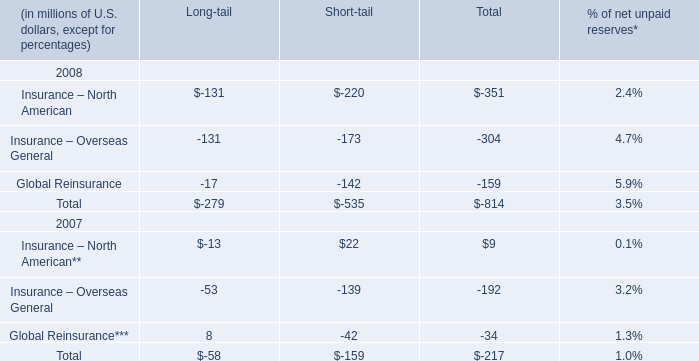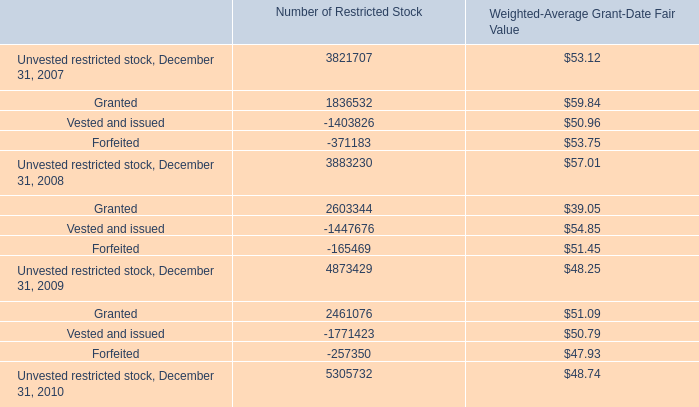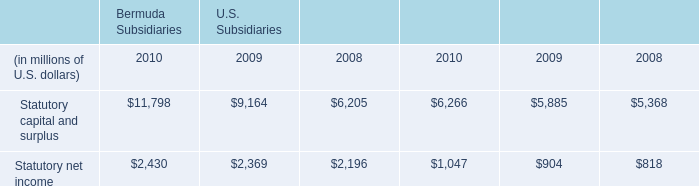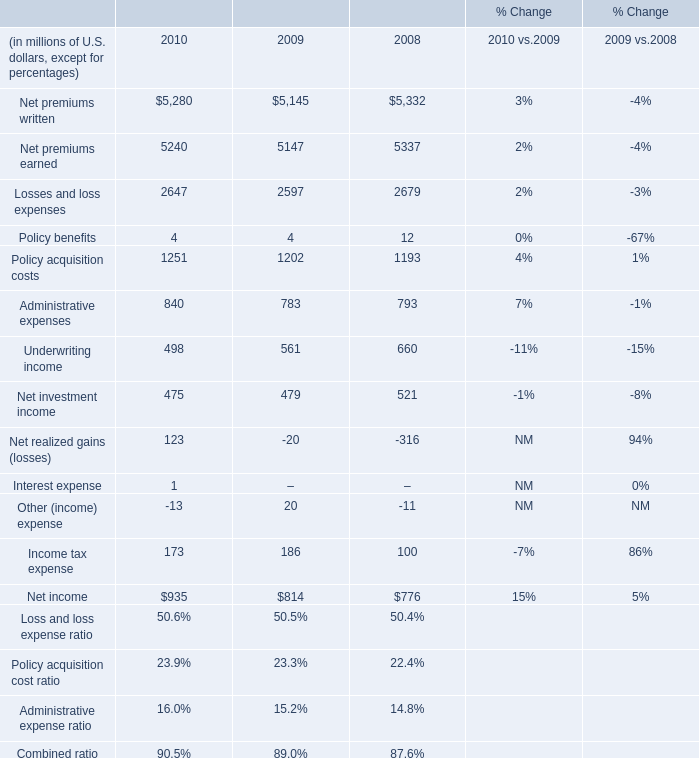What was the average of the Policy acquisition costs in the years where Policy benefits is positive? (in million) 
Computations: (((1251 + 1202) + 1193) / 3)
Answer: 1215.33333. 